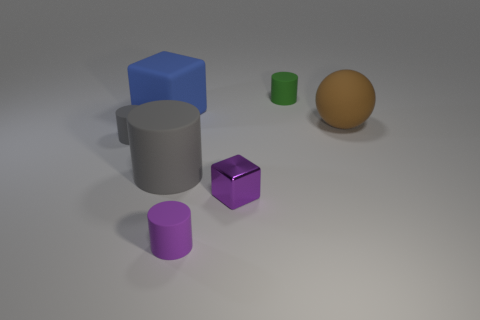There is a cube that is made of the same material as the small green thing; what is its color?
Your answer should be compact. Blue. The rubber cylinder behind the rubber thing on the right side of the tiny rubber cylinder that is behind the tiny gray matte object is what color?
Offer a very short reply. Green. How many cubes are cyan metal objects or shiny things?
Your answer should be compact. 1. What is the material of the small cylinder that is the same color as the shiny thing?
Keep it short and to the point. Rubber. There is a metallic object; is its color the same as the cylinder that is in front of the large gray thing?
Your response must be concise. Yes. What color is the large block?
Make the answer very short. Blue. What number of things are tiny purple things or brown balls?
Give a very brief answer. 3. There is a blue cube that is the same size as the brown matte object; what is its material?
Your answer should be compact. Rubber. There is a rubber cylinder that is in front of the metallic object; what is its size?
Offer a very short reply. Small. What is the small block made of?
Your response must be concise. Metal. 